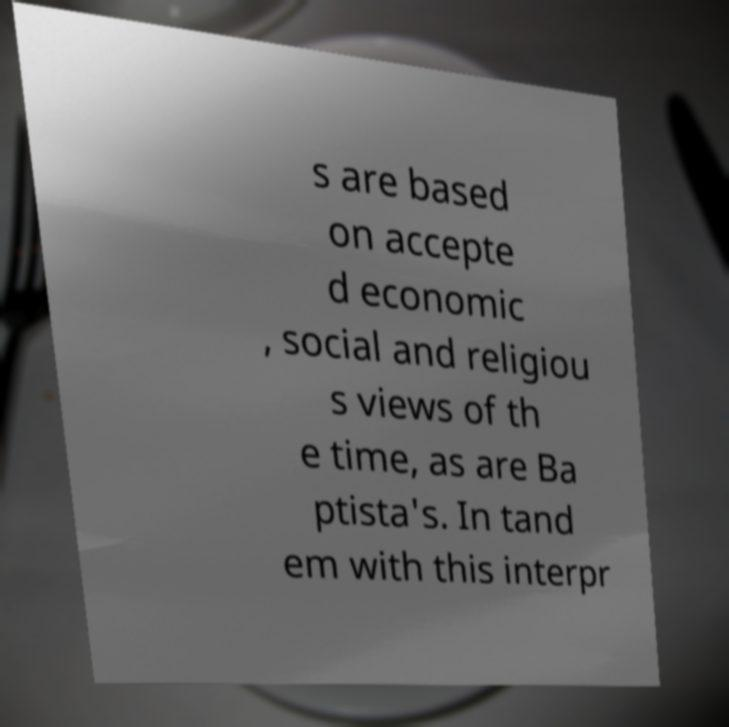I need the written content from this picture converted into text. Can you do that? s are based on accepte d economic , social and religiou s views of th e time, as are Ba ptista's. In tand em with this interpr 